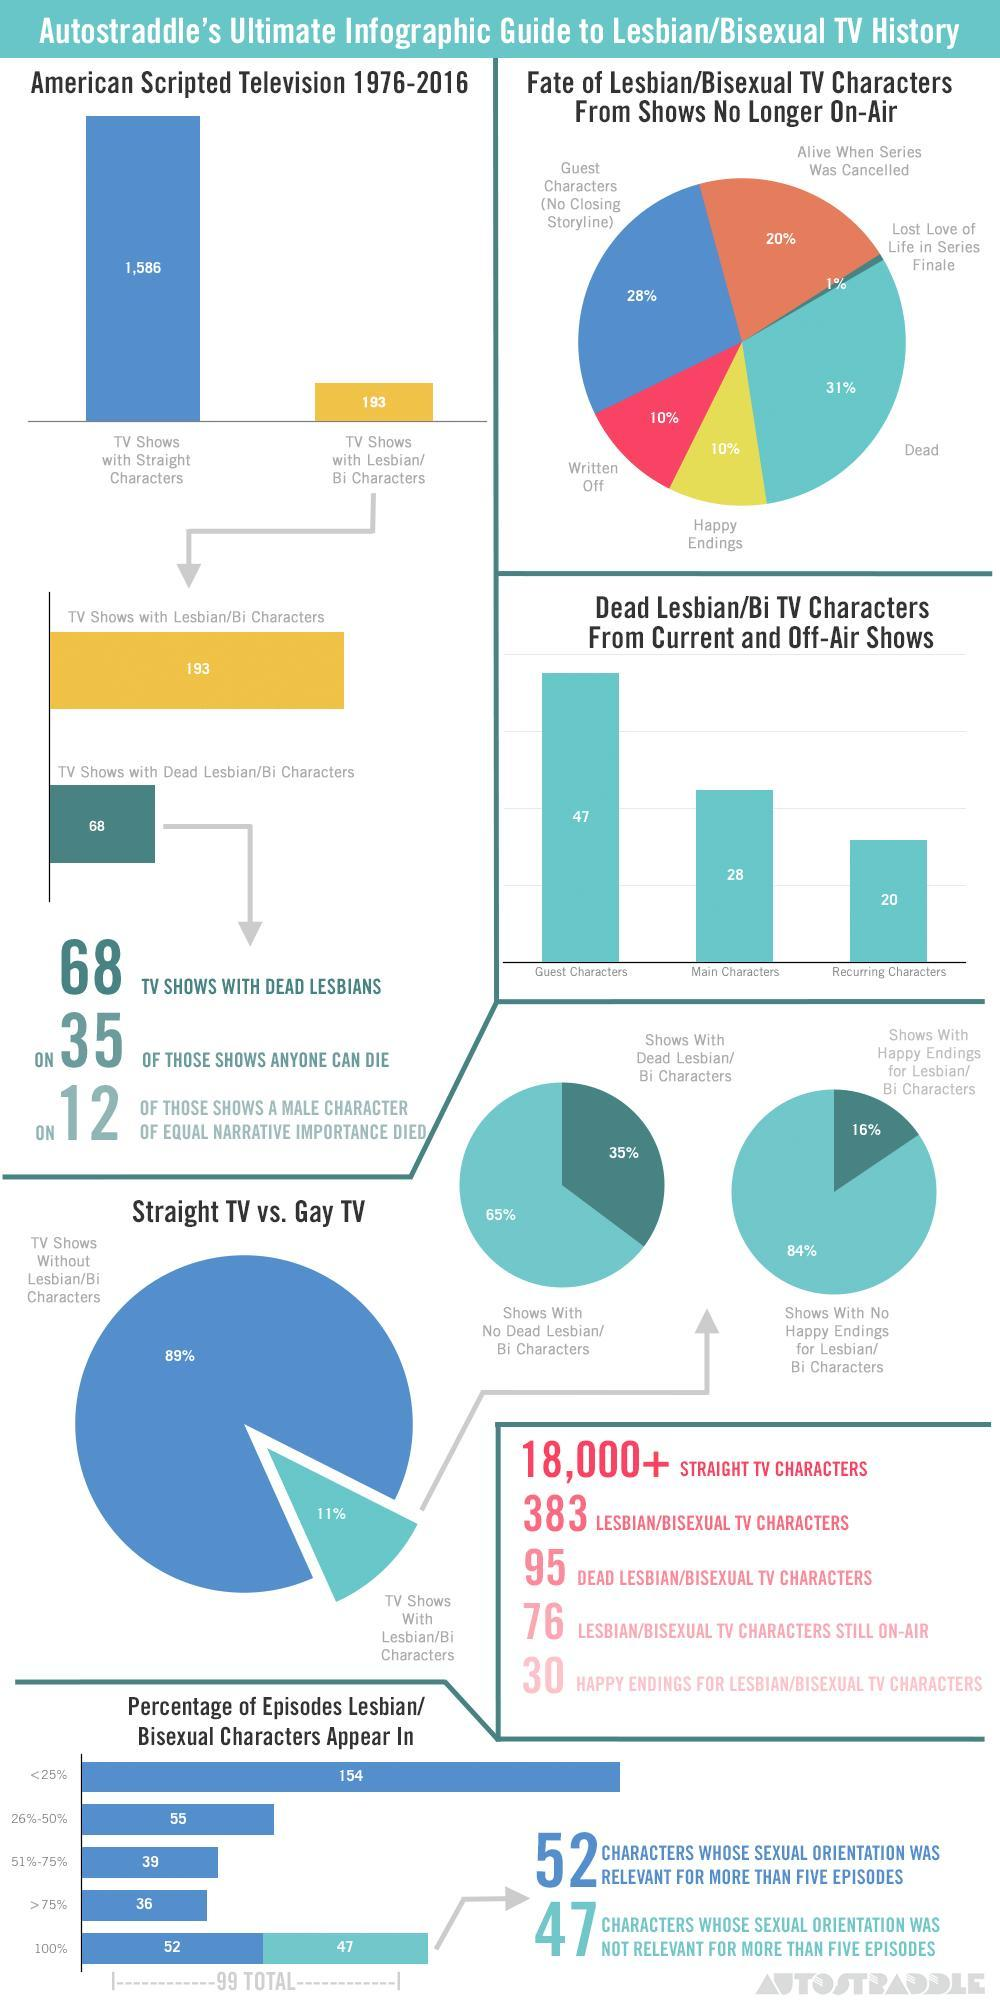Which color represents the Lesbian/Bisexual TV characters from shows no longer on-air were alive when series was cancelled, blue, brown or yellow?
Answer the question with a short phrase. brown What percentage of Lesbian/Bisexual TV characters from shows no longer on-air were Written off or were guest characters? 38% What percentage of Lesbian/Bisexual TV characters from shows no longer on-air were Written off? 10% What is the difference in percentage with shows with dead lesbian/Bi characters and shows with no dead lesbian/Bi characters? 30% What percentage of Lesbian/Bisexual TV characters from shows no longer on-air had happy endings? 10% How many more TV Shows are there with straight characters compared to TV shows with Lesbian/Bi characters? 1,393 What percentage of Lesbian/Bisexual TV characters from shows no longer on-air were alive when series was cancelled? 20% What color represents Tv shows without Lesbian/Bi characters in the pie chart, blue or green? blue 